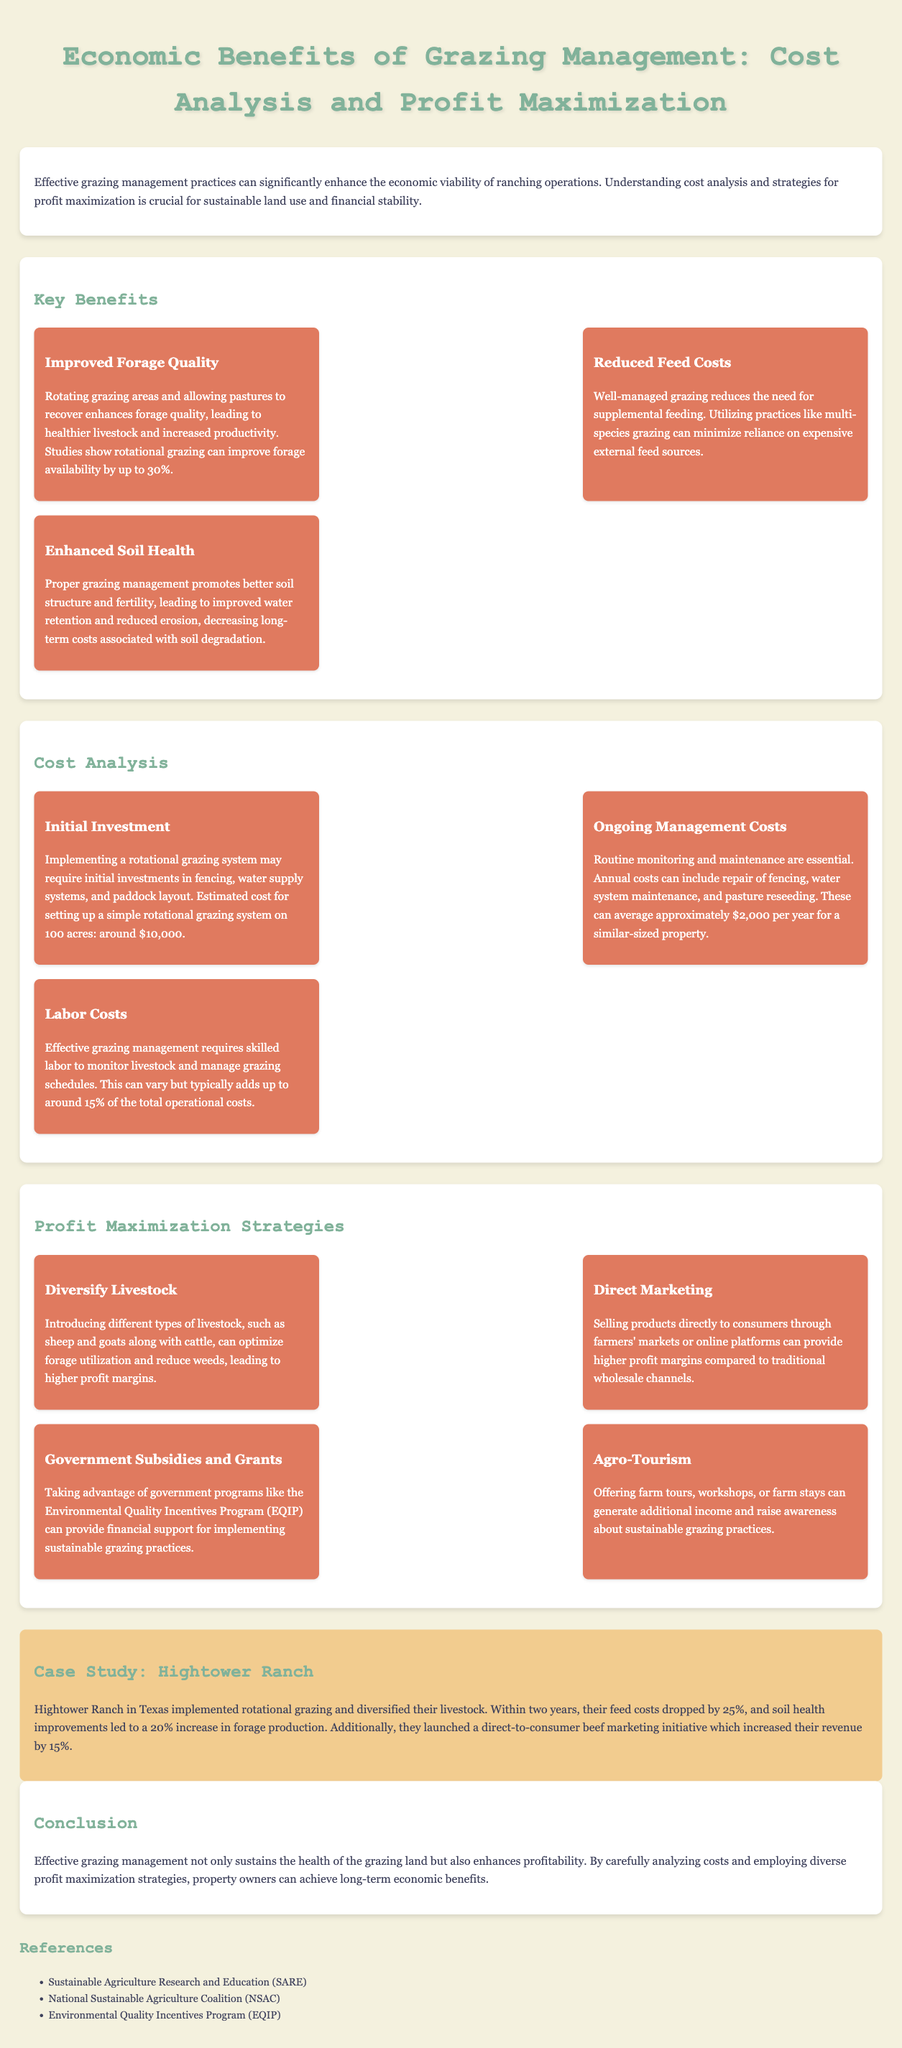What are the benefits of improved forage quality? Improved forage quality leads to healthier livestock and increased productivity, with studies showing rotational grazing can improve forage availability by up to 30%.
Answer: Healthy livestock, increased productivity, up to 30% What is the estimated initial investment for a rotational grazing system on 100 acres? The document states that the estimated cost for setting up a simple rotational grazing system on 100 acres is around $10,000.
Answer: $10,000 What percentage of total operational costs do labor costs typically add up to? The document mentions that labor costs typically add up to around 15% of the total operational costs.
Answer: 15% What direct marketing strategy can increase profit margins? Selling products directly to consumers through farmers' markets or online platforms can provide higher profit margins compared to traditional wholesale channels.
Answer: Direct marketing What farm management practice helps promote better soil structure and fertility? Proper grazing management helps promote better soil structure and fertility, as stated in the document.
Answer: Proper grazing management What percentage drop in feed costs did Hightower Ranch experience? The case study reveals that Hightower Ranch experienced a 25% drop in feed costs after implementing rotational grazing.
Answer: 25% What income-generating activity is suggested for additional revenue? The document suggests offering farm tours, workshops, or farm stays to generate additional income.
Answer: Agro-Tourism What government program can provide financial support for sustainable grazing practices? The document mentions the Environmental Quality Incentives Program (EQIP) as a government program that provides financial support.
Answer: Environmental Quality Incentives Program (EQIP) 